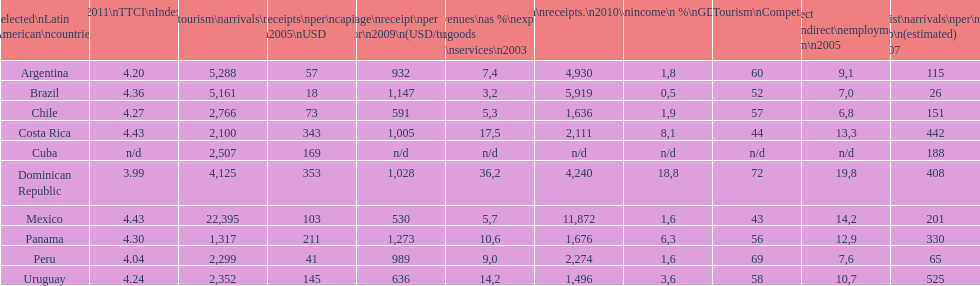What country makes the most tourist income? Dominican Republic. 